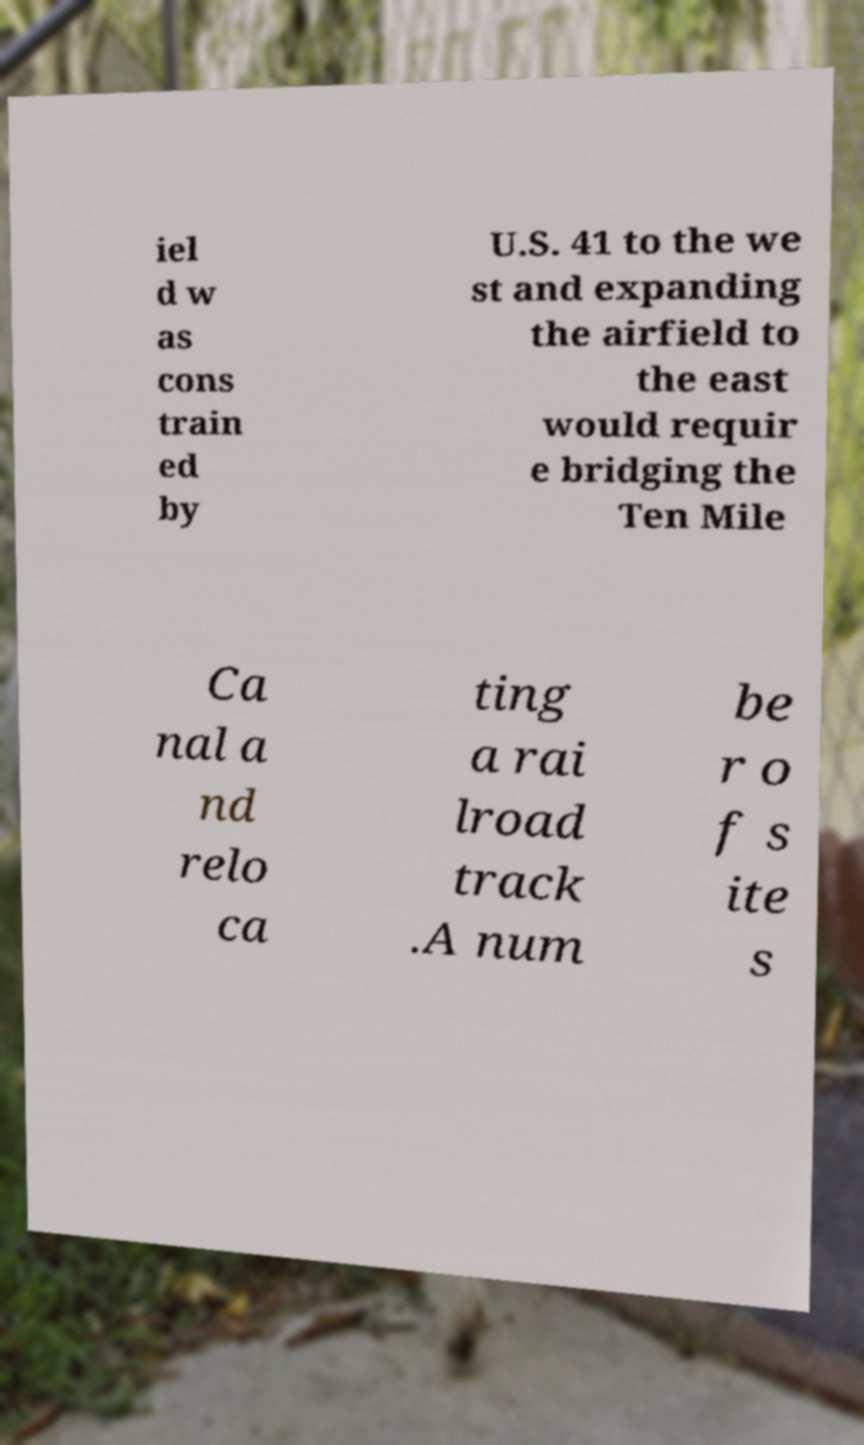Can you read and provide the text displayed in the image?This photo seems to have some interesting text. Can you extract and type it out for me? iel d w as cons train ed by U.S. 41 to the we st and expanding the airfield to the east would requir e bridging the Ten Mile Ca nal a nd relo ca ting a rai lroad track .A num be r o f s ite s 